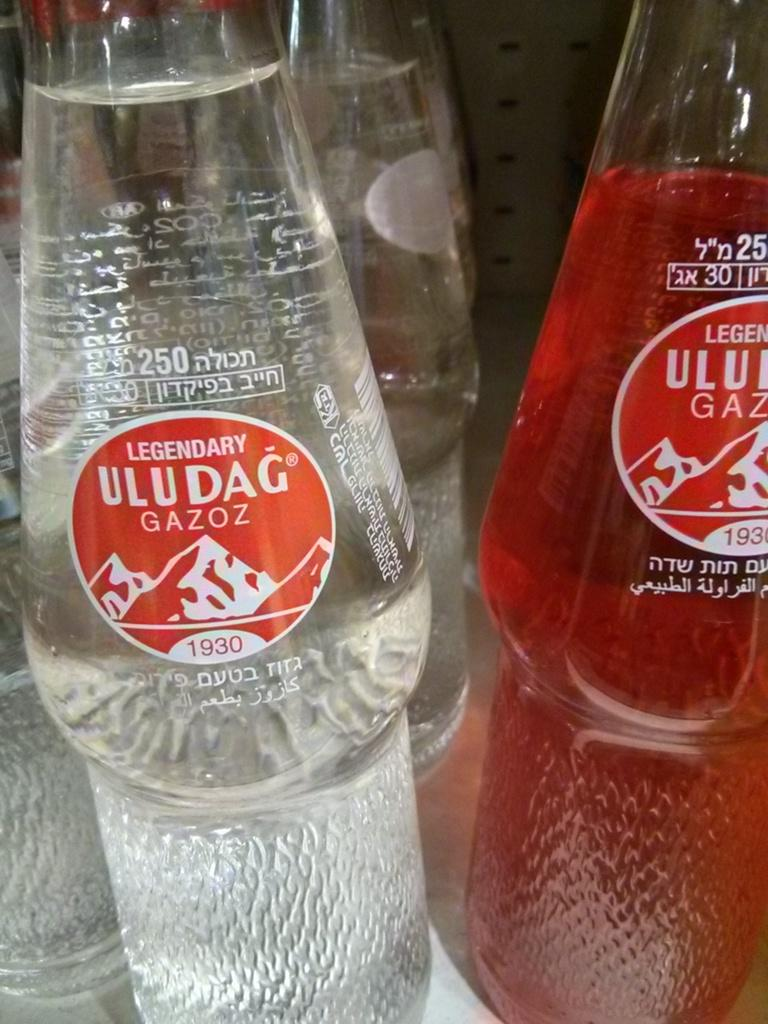How many soft drink bottles are visible in the image? There are two soft drink bottles in the image. What colors are the liquids in the bottles? The left side bottle contains transparent liquid, while the right side bottle contains red liquid. Are there any other bottles similar to the ones in the foreground? Yes, there are other similar bottles visible in the background. Can you see a fireman holding a ladybug on the right side bottle? No, there is no fireman or ladybug present in the image. 